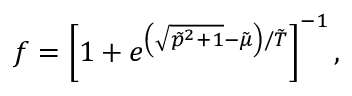Convert formula to latex. <formula><loc_0><loc_0><loc_500><loc_500>f = \left [ 1 + e ^ { \left ( \sqrt { \tilde { p } ^ { 2 } + 1 } - \tilde { \mu } \right ) / \tilde { T } } \right ] ^ { - 1 } ,</formula> 